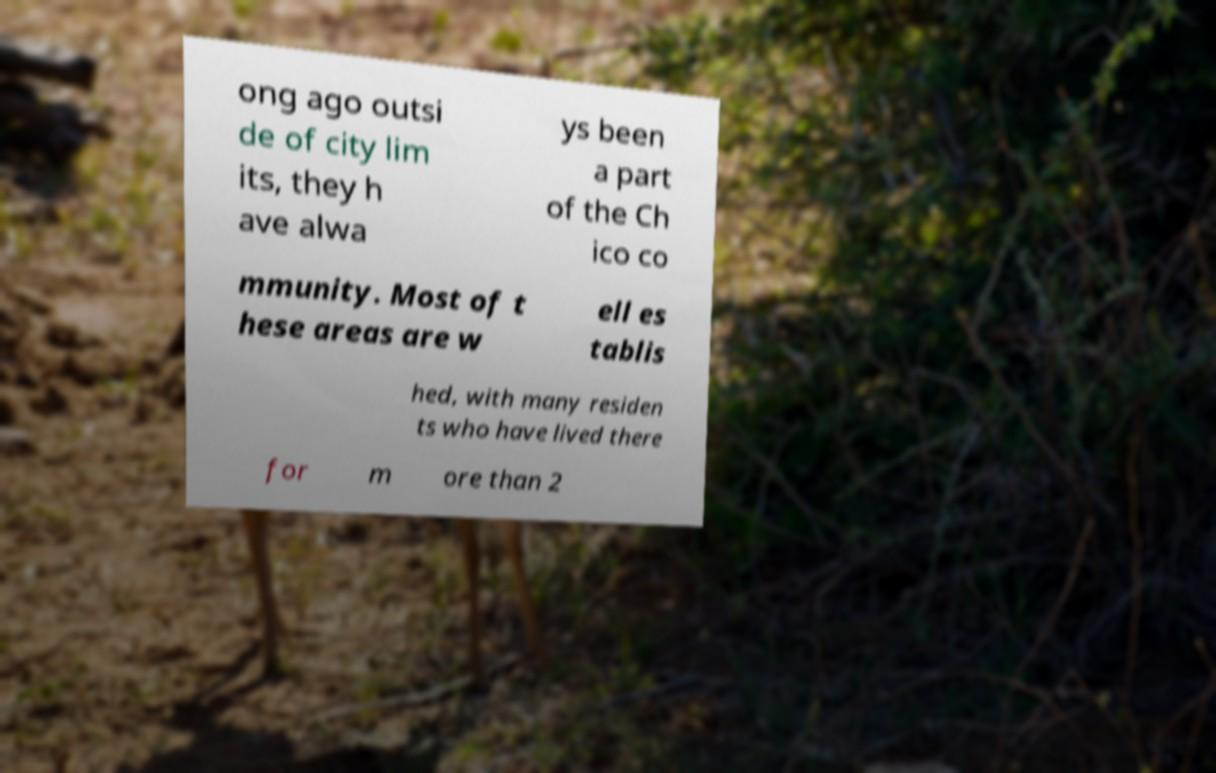Please read and relay the text visible in this image. What does it say? ong ago outsi de of city lim its, they h ave alwa ys been a part of the Ch ico co mmunity. Most of t hese areas are w ell es tablis hed, with many residen ts who have lived there for m ore than 2 